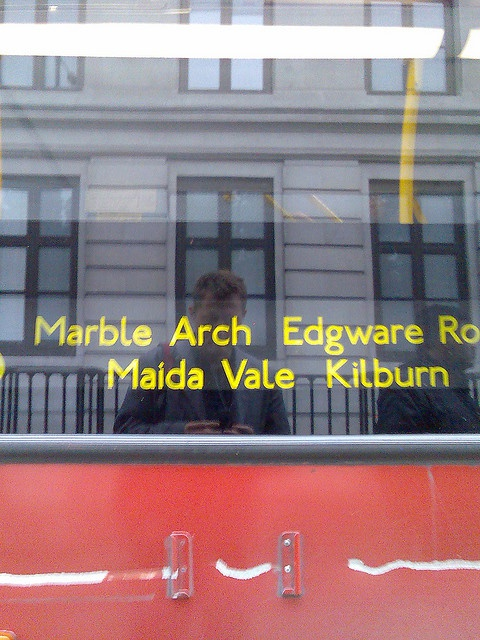Describe the objects in this image and their specific colors. I can see bus in salmon, darkgray, gray, and white tones, people in darkgray, black, gray, and yellow tones, and people in darkgray, black, gray, and blue tones in this image. 